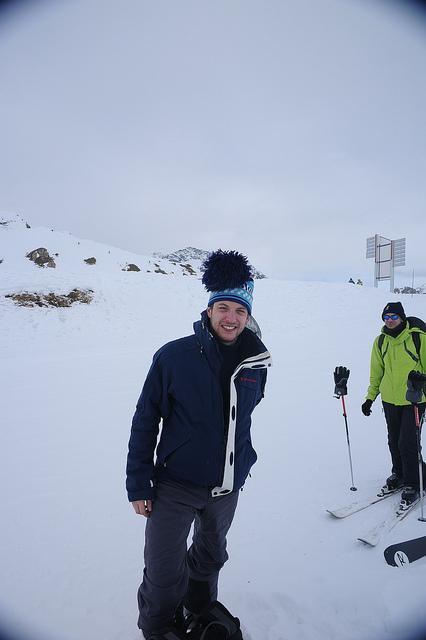How many people can be seen?
Give a very brief answer. 2. How many of the zebras are standing up?
Give a very brief answer. 0. 